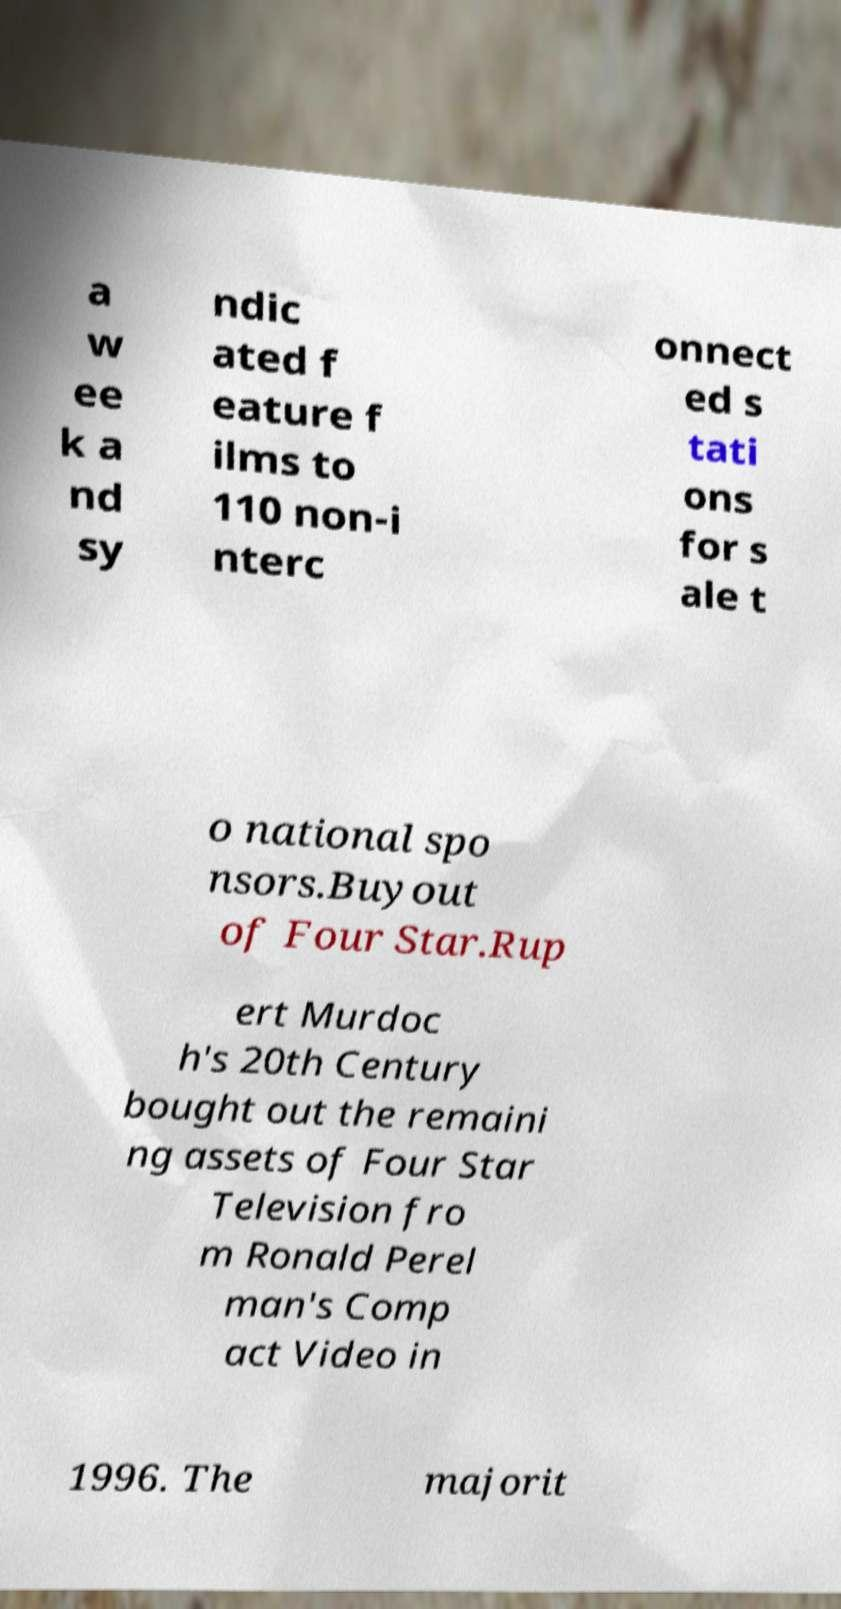Can you read and provide the text displayed in the image?This photo seems to have some interesting text. Can you extract and type it out for me? a w ee k a nd sy ndic ated f eature f ilms to 110 non-i nterc onnect ed s tati ons for s ale t o national spo nsors.Buyout of Four Star.Rup ert Murdoc h's 20th Century bought out the remaini ng assets of Four Star Television fro m Ronald Perel man's Comp act Video in 1996. The majorit 